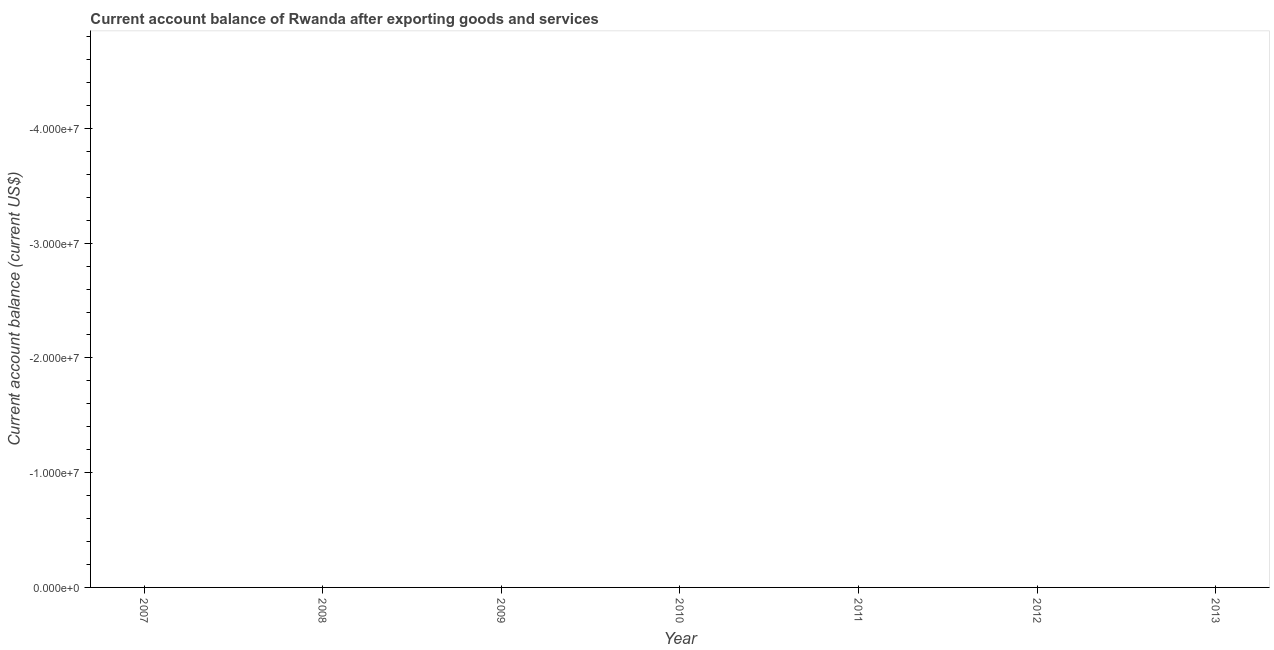What is the current account balance in 2008?
Make the answer very short. 0. Across all years, what is the minimum current account balance?
Give a very brief answer. 0. What is the sum of the current account balance?
Offer a very short reply. 0. What is the average current account balance per year?
Your response must be concise. 0. What is the median current account balance?
Your answer should be very brief. 0. Does the current account balance monotonically increase over the years?
Give a very brief answer. No. How many years are there in the graph?
Make the answer very short. 7. Are the values on the major ticks of Y-axis written in scientific E-notation?
Your answer should be compact. Yes. Does the graph contain any zero values?
Your response must be concise. Yes. Does the graph contain grids?
Your answer should be very brief. No. What is the title of the graph?
Your response must be concise. Current account balance of Rwanda after exporting goods and services. What is the label or title of the Y-axis?
Your answer should be very brief. Current account balance (current US$). What is the Current account balance (current US$) in 2007?
Your answer should be compact. 0. What is the Current account balance (current US$) in 2008?
Your answer should be compact. 0. What is the Current account balance (current US$) in 2009?
Ensure brevity in your answer.  0. What is the Current account balance (current US$) in 2010?
Give a very brief answer. 0. What is the Current account balance (current US$) in 2011?
Give a very brief answer. 0. What is the Current account balance (current US$) in 2012?
Your answer should be compact. 0. 